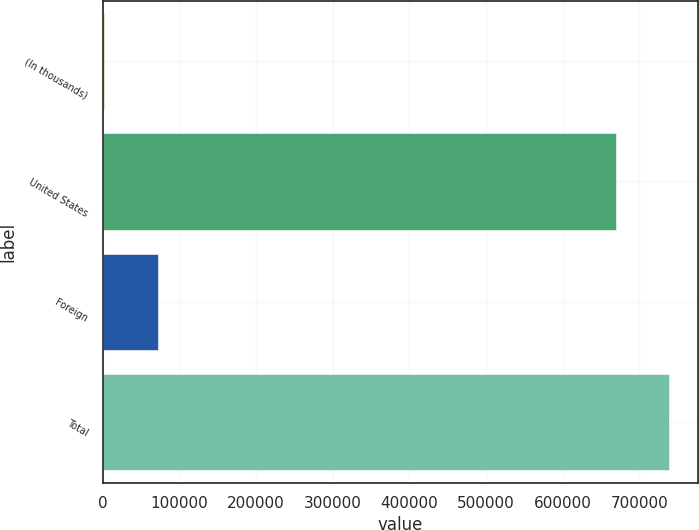Convert chart to OTSL. <chart><loc_0><loc_0><loc_500><loc_500><bar_chart><fcel>(In thousands)<fcel>United States<fcel>Foreign<fcel>Total<nl><fcel>2008<fcel>669746<fcel>71605.7<fcel>739344<nl></chart> 